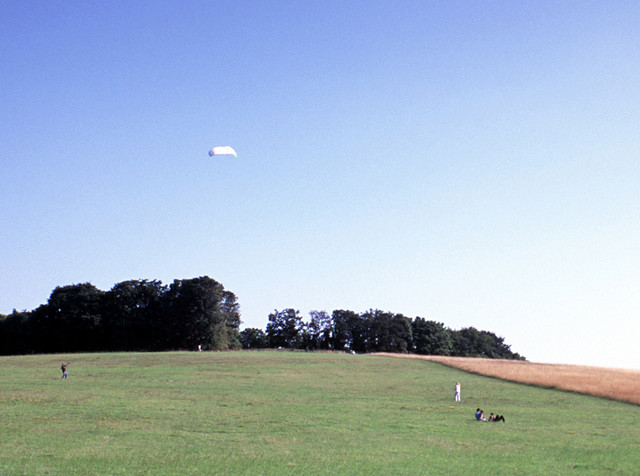What type of location is being visited?
A. swamp
B. ocean
C. field
D. forest The location being visited appears to be a wide open field. It's characterized by an expansive stretch of flat land covered with green grass and bordered by trees in the distance. The area is open to the sky above, with no large water bodies in sight, which indicates that the correct choice from the given options is 'C. field'. 